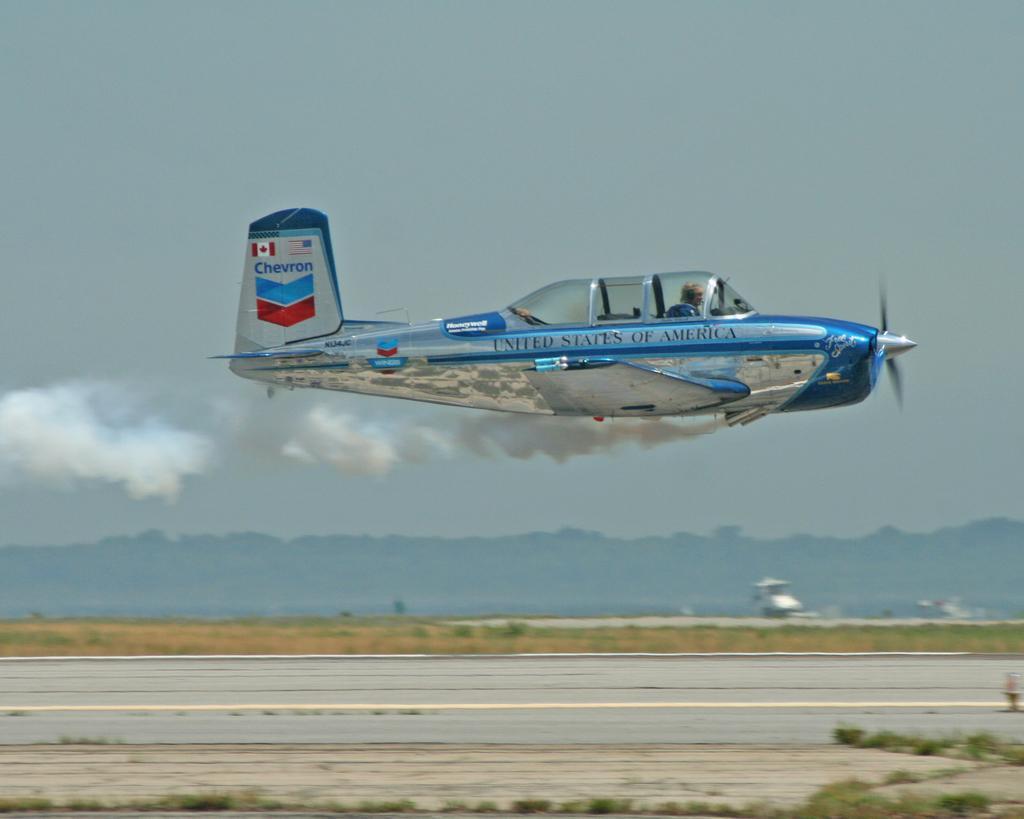Could you give a brief overview of what you see in this image? In this image there is an aircraft flying in the air. At the bottom there is runway. At the top there is the sky. It is emitting the smoke. 